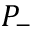Convert formula to latex. <formula><loc_0><loc_0><loc_500><loc_500>P _ { - }</formula> 